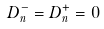Convert formula to latex. <formula><loc_0><loc_0><loc_500><loc_500>D _ { n } ^ { - } = D _ { n } ^ { + } = 0</formula> 